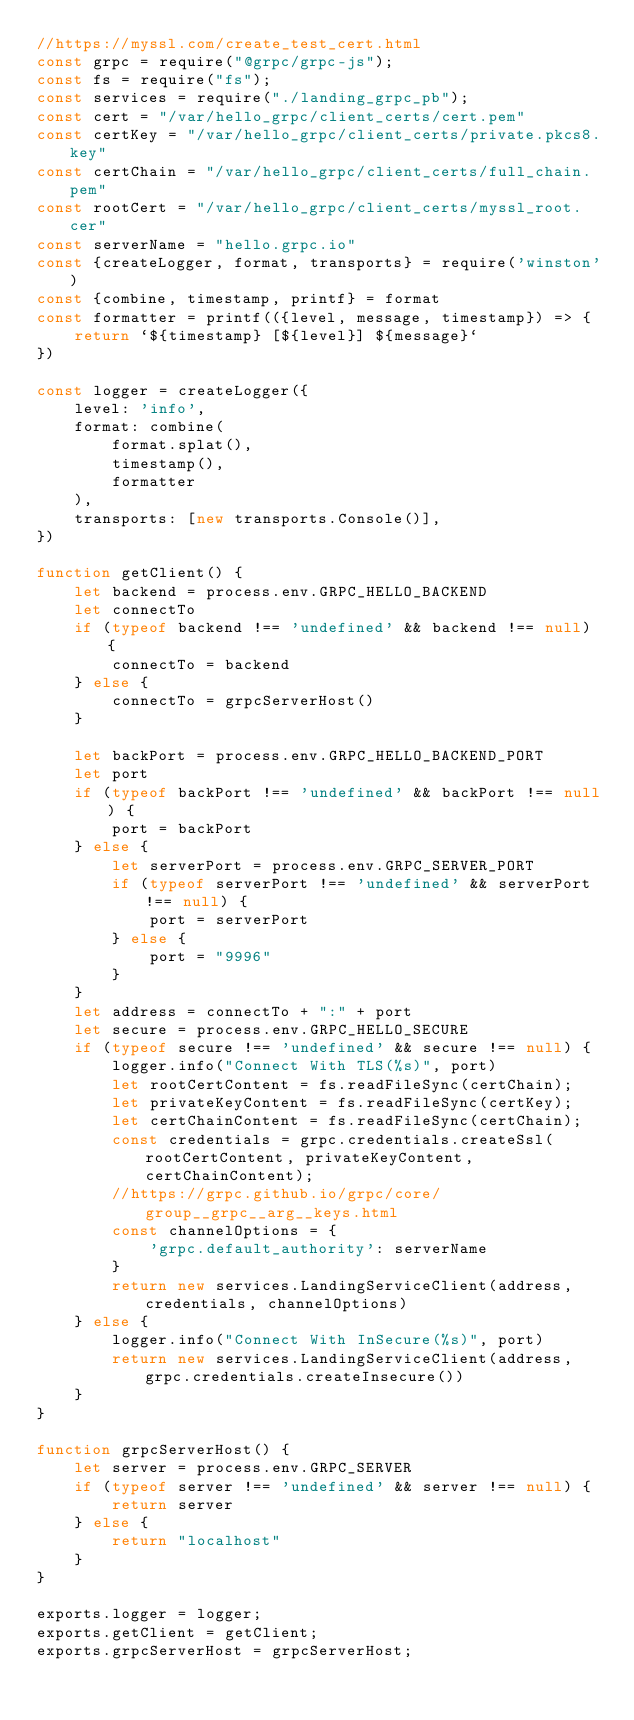<code> <loc_0><loc_0><loc_500><loc_500><_JavaScript_>//https://myssl.com/create_test_cert.html
const grpc = require("@grpc/grpc-js");
const fs = require("fs");
const services = require("./landing_grpc_pb");
const cert = "/var/hello_grpc/client_certs/cert.pem"
const certKey = "/var/hello_grpc/client_certs/private.pkcs8.key"
const certChain = "/var/hello_grpc/client_certs/full_chain.pem"
const rootCert = "/var/hello_grpc/client_certs/myssl_root.cer"
const serverName = "hello.grpc.io"
const {createLogger, format, transports} = require('winston')
const {combine, timestamp, printf} = format
const formatter = printf(({level, message, timestamp}) => {
    return `${timestamp} [${level}] ${message}`
})

const logger = createLogger({
    level: 'info',
    format: combine(
        format.splat(),
        timestamp(),
        formatter
    ),
    transports: [new transports.Console()],
})

function getClient() {
    let backend = process.env.GRPC_HELLO_BACKEND
    let connectTo
    if (typeof backend !== 'undefined' && backend !== null) {
        connectTo = backend
    } else {
        connectTo = grpcServerHost()
    }

    let backPort = process.env.GRPC_HELLO_BACKEND_PORT
    let port
    if (typeof backPort !== 'undefined' && backPort !== null) {
        port = backPort
    } else {
        let serverPort = process.env.GRPC_SERVER_PORT
        if (typeof serverPort !== 'undefined' && serverPort !== null) {
            port = serverPort
        } else {
            port = "9996"
        }
    }
    let address = connectTo + ":" + port
    let secure = process.env.GRPC_HELLO_SECURE
    if (typeof secure !== 'undefined' && secure !== null) {
        logger.info("Connect With TLS(%s)", port)
        let rootCertContent = fs.readFileSync(certChain);
        let privateKeyContent = fs.readFileSync(certKey);
        let certChainContent = fs.readFileSync(certChain);
        const credentials = grpc.credentials.createSsl(rootCertContent, privateKeyContent, certChainContent);
        //https://grpc.github.io/grpc/core/group__grpc__arg__keys.html
        const channelOptions = {
            'grpc.default_authority': serverName
        }
        return new services.LandingServiceClient(address, credentials, channelOptions)
    } else {
        logger.info("Connect With InSecure(%s)", port)
        return new services.LandingServiceClient(address, grpc.credentials.createInsecure())
    }
}

function grpcServerHost() {
    let server = process.env.GRPC_SERVER
    if (typeof server !== 'undefined' && server !== null) {
        return server
    } else {
        return "localhost"
    }
}

exports.logger = logger;
exports.getClient = getClient;
exports.grpcServerHost = grpcServerHost;</code> 